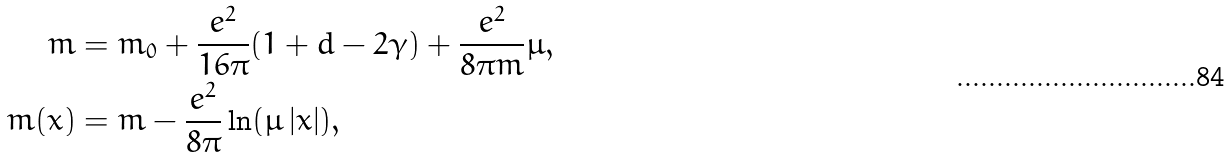<formula> <loc_0><loc_0><loc_500><loc_500>m & = m _ { 0 } + \frac { e ^ { 2 } } { 1 6 \pi } ( 1 + d - 2 \gamma ) + \frac { e ^ { 2 } } { 8 \pi m } \mu , \\ m ( x ) & = m - \frac { e ^ { 2 } } { 8 \pi } \ln ( \mu \left | x \right | ) ,</formula> 